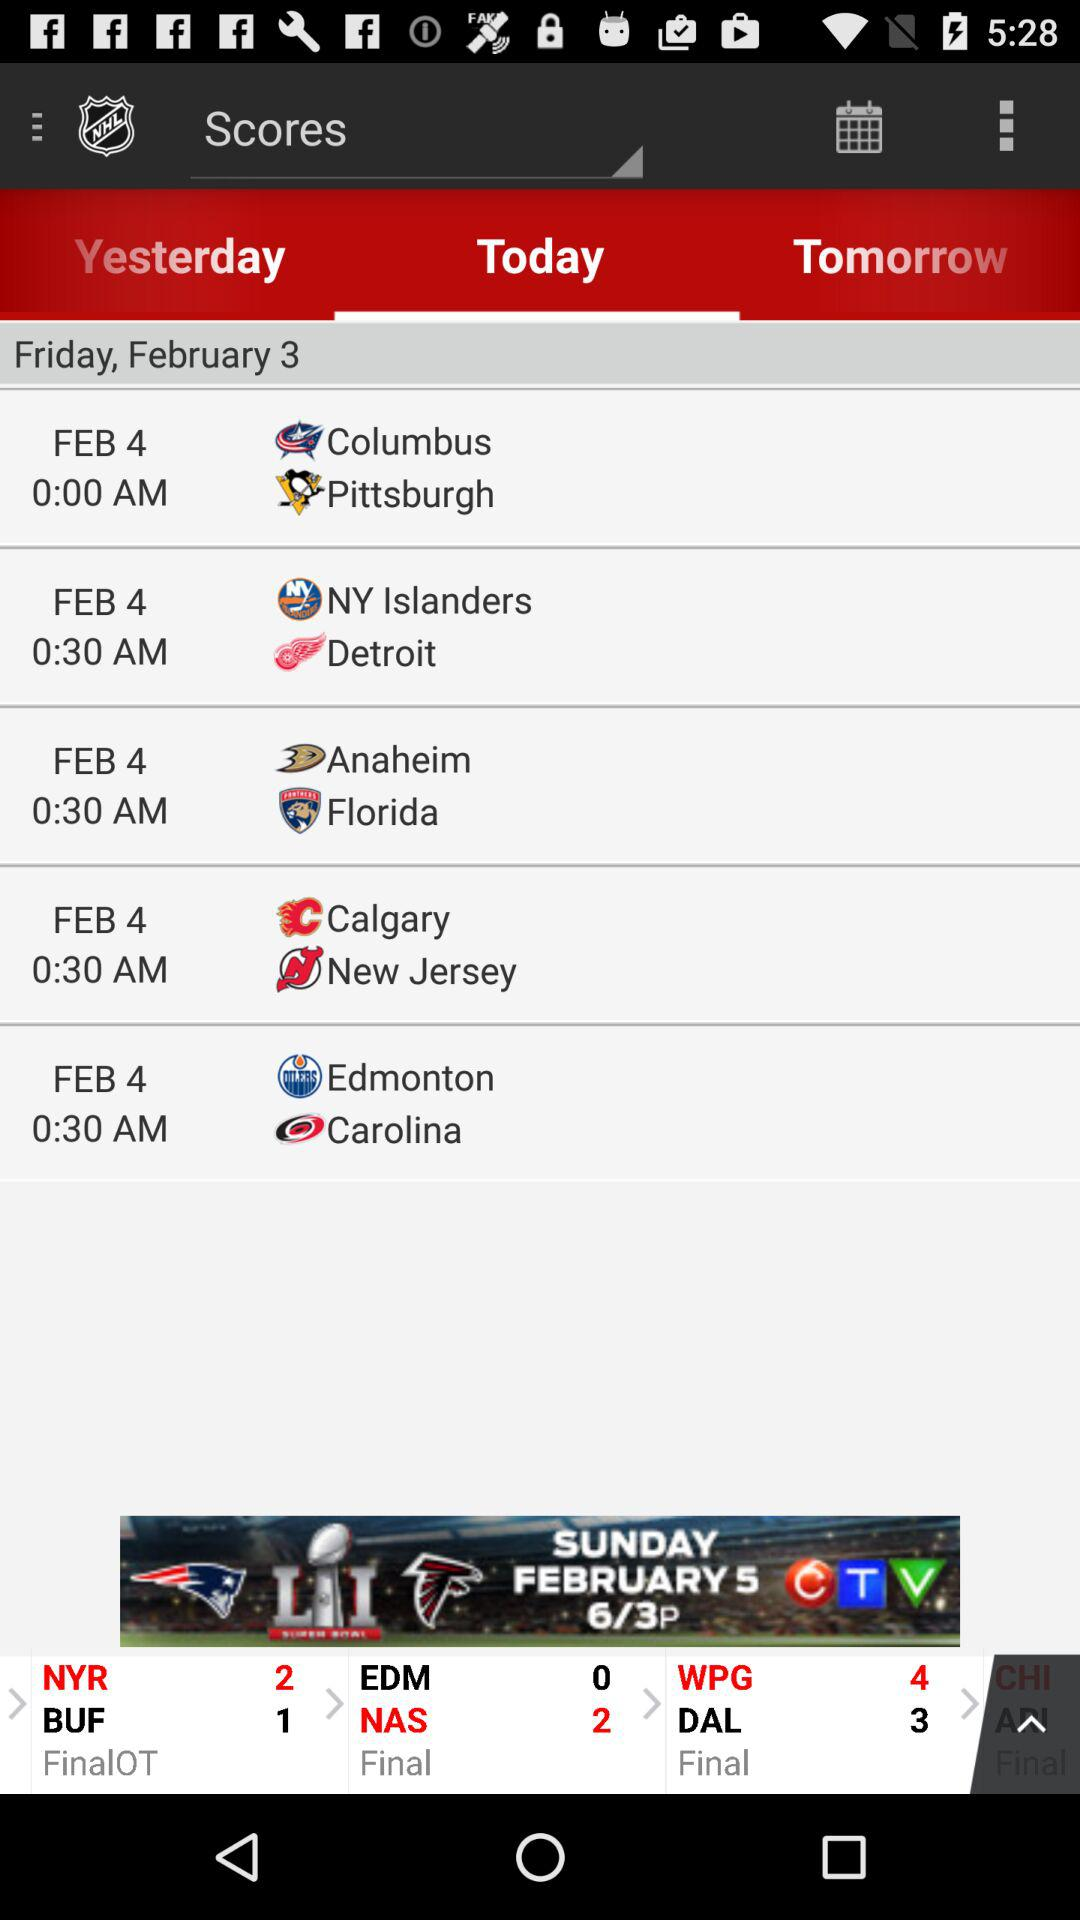What is the date of the match between "Edmonton" and "Carolina"? The date of the match is February 4. 